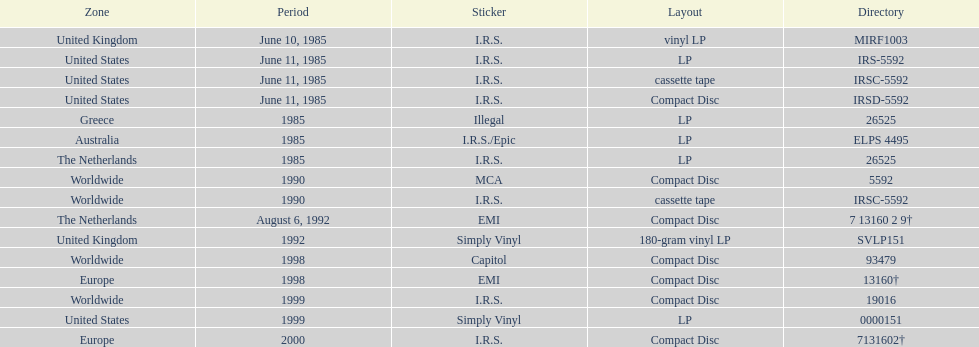How many times was the album released? 13. Would you be able to parse every entry in this table? {'header': ['Zone', 'Period', 'Sticker', 'Layout', 'Directory'], 'rows': [['United Kingdom', 'June 10, 1985', 'I.R.S.', 'vinyl LP', 'MIRF1003'], ['United States', 'June 11, 1985', 'I.R.S.', 'LP', 'IRS-5592'], ['United States', 'June 11, 1985', 'I.R.S.', 'cassette tape', 'IRSC-5592'], ['United States', 'June 11, 1985', 'I.R.S.', 'Compact Disc', 'IRSD-5592'], ['Greece', '1985', 'Illegal', 'LP', '26525'], ['Australia', '1985', 'I.R.S./Epic', 'LP', 'ELPS 4495'], ['The Netherlands', '1985', 'I.R.S.', 'LP', '26525'], ['Worldwide', '1990', 'MCA', 'Compact Disc', '5592'], ['Worldwide', '1990', 'I.R.S.', 'cassette tape', 'IRSC-5592'], ['The Netherlands', 'August 6, 1992', 'EMI', 'Compact Disc', '7 13160 2 9†'], ['United Kingdom', '1992', 'Simply Vinyl', '180-gram vinyl LP', 'SVLP151'], ['Worldwide', '1998', 'Capitol', 'Compact Disc', '93479'], ['Europe', '1998', 'EMI', 'Compact Disc', '13160†'], ['Worldwide', '1999', 'I.R.S.', 'Compact Disc', '19016'], ['United States', '1999', 'Simply Vinyl', 'LP', '0000151'], ['Europe', '2000', 'I.R.S.', 'Compact Disc', '7131602†']]} 